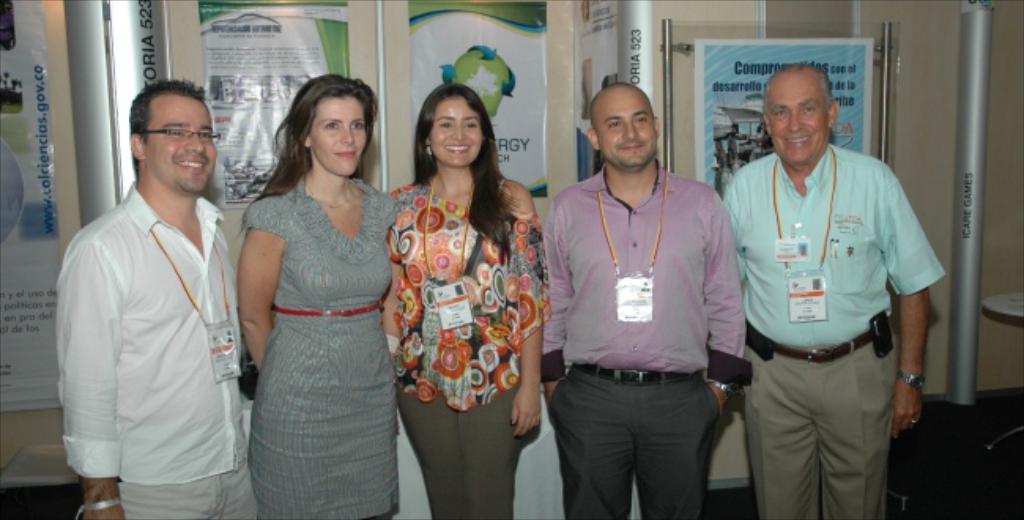Describe this image in one or two sentences. In this image we can see a group of people standing on the floor. We can also see a table, poles, some banners with text on them and a wall. 